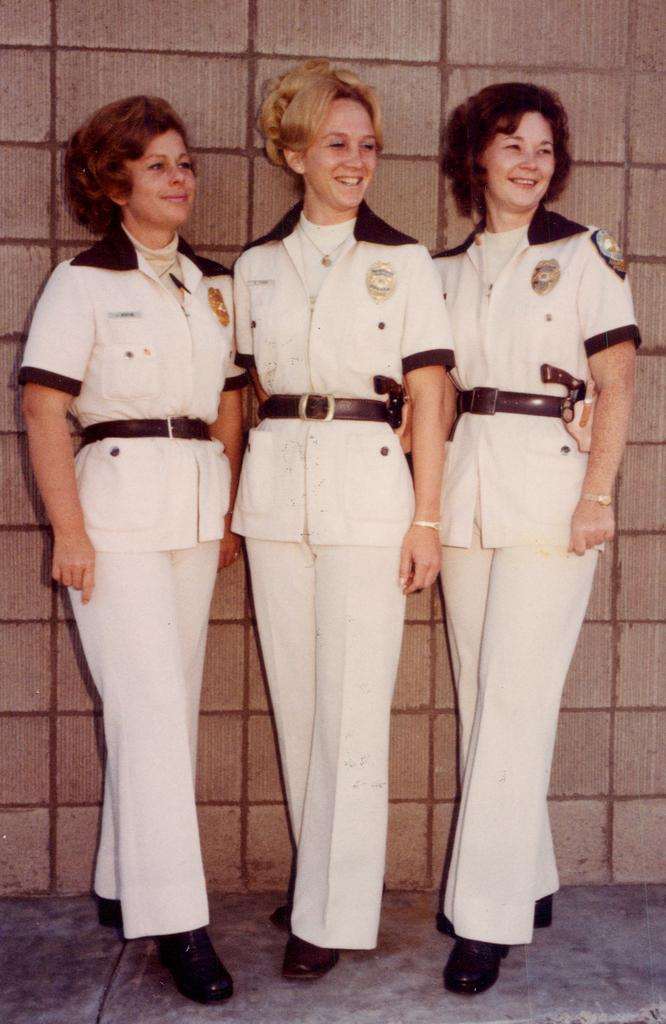How many people are in the image? There are three ladies standing in the center of the image. What is the background of the image? There is a wall at the top of the image. What is the foreground of the image? There is a floor at the bottom of the image. What type of company is represented by the logo on the ladies' shirts? There is no logo or company mentioned in the image, so it cannot be determined. 